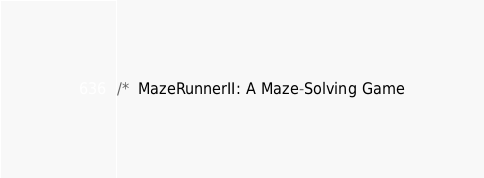<code> <loc_0><loc_0><loc_500><loc_500><_Java_>/*  MazeRunnerII: A Maze-Solving Game</code> 